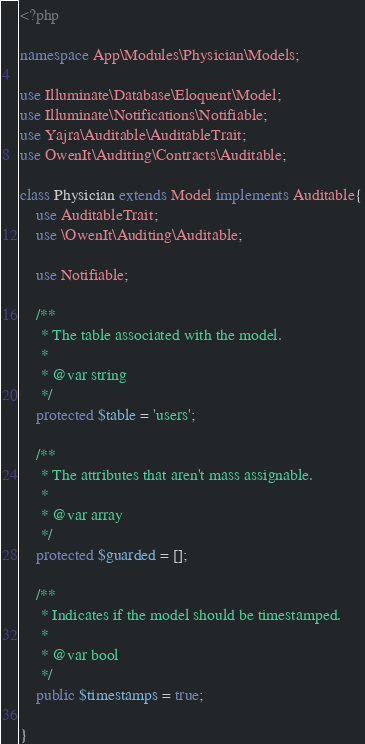Convert code to text. <code><loc_0><loc_0><loc_500><loc_500><_PHP_><?php

namespace App\Modules\Physician\Models;

use Illuminate\Database\Eloquent\Model;
use Illuminate\Notifications\Notifiable;
use Yajra\Auditable\AuditableTrait;
use OwenIt\Auditing\Contracts\Auditable;

class Physician extends Model implements Auditable{
    use AuditableTrait;
    use \OwenIt\Auditing\Auditable;

    use Notifiable;

    /**
     * The table associated with the model.
     *
     * @var string
     */
    protected $table = 'users';

    /**
     * The attributes that aren't mass assignable.
     *
     * @var array
     */
    protected $guarded = [];

    /**
     * Indicates if the model should be timestamped.
     *
     * @var bool
     */
    public $timestamps = true;

}
</code> 